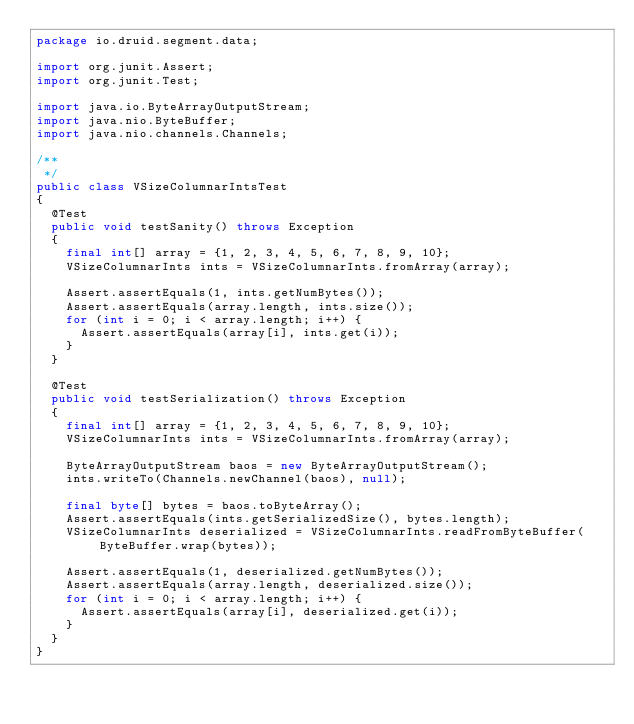<code> <loc_0><loc_0><loc_500><loc_500><_Java_>package io.druid.segment.data;

import org.junit.Assert;
import org.junit.Test;

import java.io.ByteArrayOutputStream;
import java.nio.ByteBuffer;
import java.nio.channels.Channels;

/**
 */
public class VSizeColumnarIntsTest
{
  @Test
  public void testSanity() throws Exception
  {
    final int[] array = {1, 2, 3, 4, 5, 6, 7, 8, 9, 10};
    VSizeColumnarInts ints = VSizeColumnarInts.fromArray(array);

    Assert.assertEquals(1, ints.getNumBytes());
    Assert.assertEquals(array.length, ints.size());
    for (int i = 0; i < array.length; i++) {
      Assert.assertEquals(array[i], ints.get(i));
    }
  }

  @Test
  public void testSerialization() throws Exception
  {
    final int[] array = {1, 2, 3, 4, 5, 6, 7, 8, 9, 10};
    VSizeColumnarInts ints = VSizeColumnarInts.fromArray(array);

    ByteArrayOutputStream baos = new ByteArrayOutputStream();
    ints.writeTo(Channels.newChannel(baos), null);

    final byte[] bytes = baos.toByteArray();
    Assert.assertEquals(ints.getSerializedSize(), bytes.length);
    VSizeColumnarInts deserialized = VSizeColumnarInts.readFromByteBuffer(ByteBuffer.wrap(bytes));

    Assert.assertEquals(1, deserialized.getNumBytes());
    Assert.assertEquals(array.length, deserialized.size());
    for (int i = 0; i < array.length; i++) {
      Assert.assertEquals(array[i], deserialized.get(i));
    }
  }
}
</code> 